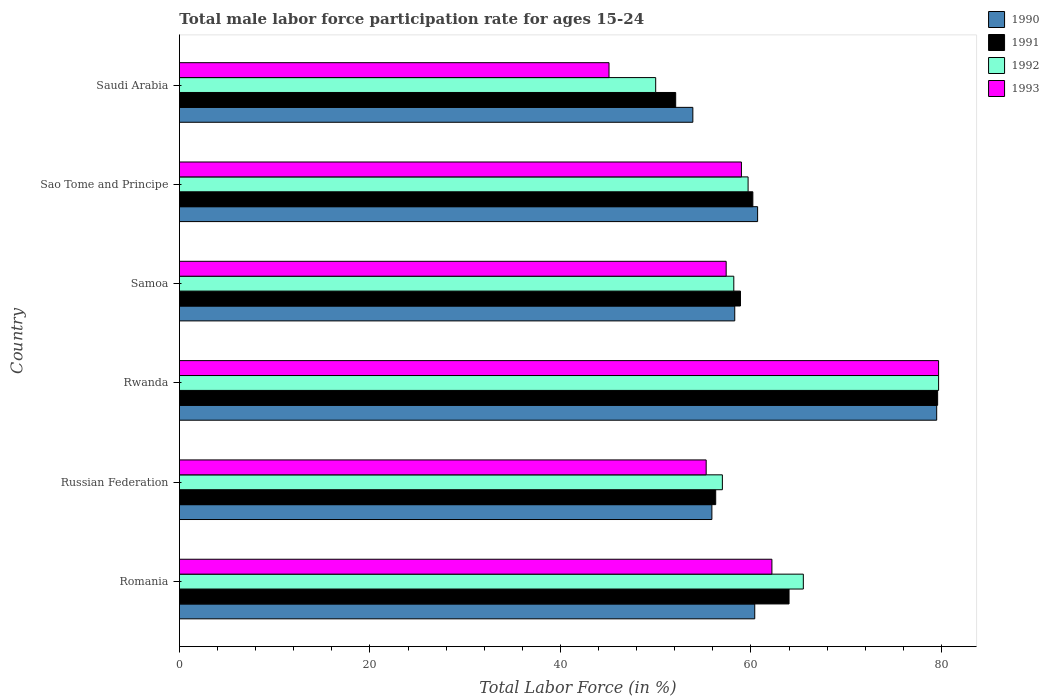Are the number of bars per tick equal to the number of legend labels?
Your answer should be compact. Yes. How many bars are there on the 2nd tick from the top?
Your answer should be very brief. 4. What is the label of the 3rd group of bars from the top?
Give a very brief answer. Samoa. In how many cases, is the number of bars for a given country not equal to the number of legend labels?
Provide a short and direct response. 0. Across all countries, what is the maximum male labor force participation rate in 1991?
Make the answer very short. 79.6. In which country was the male labor force participation rate in 1993 maximum?
Offer a terse response. Rwanda. In which country was the male labor force participation rate in 1993 minimum?
Your response must be concise. Saudi Arabia. What is the total male labor force participation rate in 1990 in the graph?
Ensure brevity in your answer.  368.7. What is the difference between the male labor force participation rate in 1993 in Samoa and that in Sao Tome and Principe?
Your answer should be compact. -1.6. What is the difference between the male labor force participation rate in 1991 in Romania and the male labor force participation rate in 1990 in Samoa?
Keep it short and to the point. 5.7. What is the average male labor force participation rate in 1991 per country?
Keep it short and to the point. 61.85. What is the difference between the male labor force participation rate in 1990 and male labor force participation rate in 1993 in Russian Federation?
Your answer should be compact. 0.6. In how many countries, is the male labor force participation rate in 1992 greater than 64 %?
Your answer should be compact. 2. What is the ratio of the male labor force participation rate in 1992 in Rwanda to that in Sao Tome and Principe?
Provide a short and direct response. 1.34. Is the difference between the male labor force participation rate in 1990 in Romania and Russian Federation greater than the difference between the male labor force participation rate in 1993 in Romania and Russian Federation?
Make the answer very short. No. What is the difference between the highest and the second highest male labor force participation rate in 1993?
Provide a succinct answer. 17.5. What is the difference between the highest and the lowest male labor force participation rate in 1993?
Ensure brevity in your answer.  34.6. In how many countries, is the male labor force participation rate in 1990 greater than the average male labor force participation rate in 1990 taken over all countries?
Provide a short and direct response. 1. What does the 4th bar from the top in Sao Tome and Principe represents?
Your answer should be very brief. 1990. What does the 1st bar from the bottom in Romania represents?
Offer a very short reply. 1990. Are the values on the major ticks of X-axis written in scientific E-notation?
Your response must be concise. No. Does the graph contain any zero values?
Offer a very short reply. No. Where does the legend appear in the graph?
Provide a succinct answer. Top right. How are the legend labels stacked?
Offer a terse response. Vertical. What is the title of the graph?
Make the answer very short. Total male labor force participation rate for ages 15-24. What is the label or title of the X-axis?
Offer a very short reply. Total Labor Force (in %). What is the Total Labor Force (in %) in 1990 in Romania?
Offer a terse response. 60.4. What is the Total Labor Force (in %) in 1992 in Romania?
Give a very brief answer. 65.5. What is the Total Labor Force (in %) of 1993 in Romania?
Your answer should be compact. 62.2. What is the Total Labor Force (in %) in 1990 in Russian Federation?
Your answer should be very brief. 55.9. What is the Total Labor Force (in %) in 1991 in Russian Federation?
Your answer should be compact. 56.3. What is the Total Labor Force (in %) in 1992 in Russian Federation?
Offer a terse response. 57. What is the Total Labor Force (in %) in 1993 in Russian Federation?
Your answer should be very brief. 55.3. What is the Total Labor Force (in %) in 1990 in Rwanda?
Keep it short and to the point. 79.5. What is the Total Labor Force (in %) of 1991 in Rwanda?
Provide a succinct answer. 79.6. What is the Total Labor Force (in %) in 1992 in Rwanda?
Offer a terse response. 79.7. What is the Total Labor Force (in %) in 1993 in Rwanda?
Your answer should be compact. 79.7. What is the Total Labor Force (in %) of 1990 in Samoa?
Provide a succinct answer. 58.3. What is the Total Labor Force (in %) in 1991 in Samoa?
Your response must be concise. 58.9. What is the Total Labor Force (in %) of 1992 in Samoa?
Provide a short and direct response. 58.2. What is the Total Labor Force (in %) in 1993 in Samoa?
Offer a very short reply. 57.4. What is the Total Labor Force (in %) in 1990 in Sao Tome and Principe?
Provide a succinct answer. 60.7. What is the Total Labor Force (in %) of 1991 in Sao Tome and Principe?
Make the answer very short. 60.2. What is the Total Labor Force (in %) in 1992 in Sao Tome and Principe?
Your response must be concise. 59.7. What is the Total Labor Force (in %) in 1993 in Sao Tome and Principe?
Provide a succinct answer. 59. What is the Total Labor Force (in %) of 1990 in Saudi Arabia?
Your response must be concise. 53.9. What is the Total Labor Force (in %) of 1991 in Saudi Arabia?
Keep it short and to the point. 52.1. What is the Total Labor Force (in %) in 1992 in Saudi Arabia?
Offer a terse response. 50. What is the Total Labor Force (in %) in 1993 in Saudi Arabia?
Provide a short and direct response. 45.1. Across all countries, what is the maximum Total Labor Force (in %) of 1990?
Offer a terse response. 79.5. Across all countries, what is the maximum Total Labor Force (in %) in 1991?
Your answer should be very brief. 79.6. Across all countries, what is the maximum Total Labor Force (in %) of 1992?
Your answer should be very brief. 79.7. Across all countries, what is the maximum Total Labor Force (in %) of 1993?
Ensure brevity in your answer.  79.7. Across all countries, what is the minimum Total Labor Force (in %) of 1990?
Your answer should be compact. 53.9. Across all countries, what is the minimum Total Labor Force (in %) of 1991?
Give a very brief answer. 52.1. Across all countries, what is the minimum Total Labor Force (in %) in 1992?
Your answer should be very brief. 50. Across all countries, what is the minimum Total Labor Force (in %) of 1993?
Your answer should be compact. 45.1. What is the total Total Labor Force (in %) in 1990 in the graph?
Offer a very short reply. 368.7. What is the total Total Labor Force (in %) of 1991 in the graph?
Your response must be concise. 371.1. What is the total Total Labor Force (in %) of 1992 in the graph?
Offer a very short reply. 370.1. What is the total Total Labor Force (in %) of 1993 in the graph?
Offer a very short reply. 358.7. What is the difference between the Total Labor Force (in %) in 1991 in Romania and that in Russian Federation?
Ensure brevity in your answer.  7.7. What is the difference between the Total Labor Force (in %) in 1993 in Romania and that in Russian Federation?
Make the answer very short. 6.9. What is the difference between the Total Labor Force (in %) in 1990 in Romania and that in Rwanda?
Your answer should be very brief. -19.1. What is the difference between the Total Labor Force (in %) of 1991 in Romania and that in Rwanda?
Your response must be concise. -15.6. What is the difference between the Total Labor Force (in %) of 1992 in Romania and that in Rwanda?
Your answer should be compact. -14.2. What is the difference between the Total Labor Force (in %) in 1993 in Romania and that in Rwanda?
Offer a terse response. -17.5. What is the difference between the Total Labor Force (in %) in 1990 in Romania and that in Samoa?
Your response must be concise. 2.1. What is the difference between the Total Labor Force (in %) in 1992 in Romania and that in Samoa?
Keep it short and to the point. 7.3. What is the difference between the Total Labor Force (in %) in 1990 in Romania and that in Sao Tome and Principe?
Provide a succinct answer. -0.3. What is the difference between the Total Labor Force (in %) in 1991 in Romania and that in Sao Tome and Principe?
Your answer should be very brief. 3.8. What is the difference between the Total Labor Force (in %) of 1992 in Romania and that in Sao Tome and Principe?
Ensure brevity in your answer.  5.8. What is the difference between the Total Labor Force (in %) in 1990 in Romania and that in Saudi Arabia?
Ensure brevity in your answer.  6.5. What is the difference between the Total Labor Force (in %) in 1992 in Romania and that in Saudi Arabia?
Your answer should be compact. 15.5. What is the difference between the Total Labor Force (in %) of 1990 in Russian Federation and that in Rwanda?
Make the answer very short. -23.6. What is the difference between the Total Labor Force (in %) in 1991 in Russian Federation and that in Rwanda?
Your answer should be very brief. -23.3. What is the difference between the Total Labor Force (in %) in 1992 in Russian Federation and that in Rwanda?
Offer a very short reply. -22.7. What is the difference between the Total Labor Force (in %) in 1993 in Russian Federation and that in Rwanda?
Your answer should be very brief. -24.4. What is the difference between the Total Labor Force (in %) in 1990 in Russian Federation and that in Samoa?
Give a very brief answer. -2.4. What is the difference between the Total Labor Force (in %) in 1991 in Russian Federation and that in Samoa?
Your answer should be compact. -2.6. What is the difference between the Total Labor Force (in %) in 1992 in Russian Federation and that in Sao Tome and Principe?
Your response must be concise. -2.7. What is the difference between the Total Labor Force (in %) of 1993 in Russian Federation and that in Sao Tome and Principe?
Provide a succinct answer. -3.7. What is the difference between the Total Labor Force (in %) in 1992 in Russian Federation and that in Saudi Arabia?
Your answer should be very brief. 7. What is the difference between the Total Labor Force (in %) in 1990 in Rwanda and that in Samoa?
Offer a very short reply. 21.2. What is the difference between the Total Labor Force (in %) of 1991 in Rwanda and that in Samoa?
Keep it short and to the point. 20.7. What is the difference between the Total Labor Force (in %) of 1992 in Rwanda and that in Samoa?
Provide a short and direct response. 21.5. What is the difference between the Total Labor Force (in %) of 1993 in Rwanda and that in Samoa?
Provide a short and direct response. 22.3. What is the difference between the Total Labor Force (in %) in 1991 in Rwanda and that in Sao Tome and Principe?
Offer a very short reply. 19.4. What is the difference between the Total Labor Force (in %) of 1992 in Rwanda and that in Sao Tome and Principe?
Offer a very short reply. 20. What is the difference between the Total Labor Force (in %) of 1993 in Rwanda and that in Sao Tome and Principe?
Your answer should be very brief. 20.7. What is the difference between the Total Labor Force (in %) of 1990 in Rwanda and that in Saudi Arabia?
Ensure brevity in your answer.  25.6. What is the difference between the Total Labor Force (in %) in 1991 in Rwanda and that in Saudi Arabia?
Offer a terse response. 27.5. What is the difference between the Total Labor Force (in %) in 1992 in Rwanda and that in Saudi Arabia?
Provide a short and direct response. 29.7. What is the difference between the Total Labor Force (in %) in 1993 in Rwanda and that in Saudi Arabia?
Your response must be concise. 34.6. What is the difference between the Total Labor Force (in %) of 1991 in Samoa and that in Sao Tome and Principe?
Offer a terse response. -1.3. What is the difference between the Total Labor Force (in %) in 1992 in Samoa and that in Sao Tome and Principe?
Keep it short and to the point. -1.5. What is the difference between the Total Labor Force (in %) of 1990 in Samoa and that in Saudi Arabia?
Make the answer very short. 4.4. What is the difference between the Total Labor Force (in %) of 1991 in Samoa and that in Saudi Arabia?
Give a very brief answer. 6.8. What is the difference between the Total Labor Force (in %) of 1992 in Samoa and that in Saudi Arabia?
Provide a short and direct response. 8.2. What is the difference between the Total Labor Force (in %) in 1993 in Samoa and that in Saudi Arabia?
Offer a terse response. 12.3. What is the difference between the Total Labor Force (in %) of 1990 in Sao Tome and Principe and that in Saudi Arabia?
Your answer should be very brief. 6.8. What is the difference between the Total Labor Force (in %) in 1991 in Sao Tome and Principe and that in Saudi Arabia?
Keep it short and to the point. 8.1. What is the difference between the Total Labor Force (in %) in 1992 in Sao Tome and Principe and that in Saudi Arabia?
Give a very brief answer. 9.7. What is the difference between the Total Labor Force (in %) in 1993 in Sao Tome and Principe and that in Saudi Arabia?
Your answer should be very brief. 13.9. What is the difference between the Total Labor Force (in %) in 1991 in Romania and the Total Labor Force (in %) in 1993 in Russian Federation?
Ensure brevity in your answer.  8.7. What is the difference between the Total Labor Force (in %) of 1990 in Romania and the Total Labor Force (in %) of 1991 in Rwanda?
Keep it short and to the point. -19.2. What is the difference between the Total Labor Force (in %) of 1990 in Romania and the Total Labor Force (in %) of 1992 in Rwanda?
Your response must be concise. -19.3. What is the difference between the Total Labor Force (in %) of 1990 in Romania and the Total Labor Force (in %) of 1993 in Rwanda?
Your response must be concise. -19.3. What is the difference between the Total Labor Force (in %) in 1991 in Romania and the Total Labor Force (in %) in 1992 in Rwanda?
Your answer should be compact. -15.7. What is the difference between the Total Labor Force (in %) of 1991 in Romania and the Total Labor Force (in %) of 1993 in Rwanda?
Provide a succinct answer. -15.7. What is the difference between the Total Labor Force (in %) of 1992 in Romania and the Total Labor Force (in %) of 1993 in Rwanda?
Give a very brief answer. -14.2. What is the difference between the Total Labor Force (in %) of 1990 in Romania and the Total Labor Force (in %) of 1993 in Samoa?
Provide a short and direct response. 3. What is the difference between the Total Labor Force (in %) of 1991 in Romania and the Total Labor Force (in %) of 1992 in Samoa?
Keep it short and to the point. 5.8. What is the difference between the Total Labor Force (in %) in 1991 in Romania and the Total Labor Force (in %) in 1993 in Samoa?
Make the answer very short. 6.6. What is the difference between the Total Labor Force (in %) in 1990 in Romania and the Total Labor Force (in %) in 1991 in Sao Tome and Principe?
Make the answer very short. 0.2. What is the difference between the Total Labor Force (in %) of 1990 in Romania and the Total Labor Force (in %) of 1992 in Sao Tome and Principe?
Offer a very short reply. 0.7. What is the difference between the Total Labor Force (in %) in 1990 in Romania and the Total Labor Force (in %) in 1993 in Sao Tome and Principe?
Keep it short and to the point. 1.4. What is the difference between the Total Labor Force (in %) in 1992 in Romania and the Total Labor Force (in %) in 1993 in Sao Tome and Principe?
Provide a succinct answer. 6.5. What is the difference between the Total Labor Force (in %) of 1990 in Romania and the Total Labor Force (in %) of 1992 in Saudi Arabia?
Keep it short and to the point. 10.4. What is the difference between the Total Labor Force (in %) in 1991 in Romania and the Total Labor Force (in %) in 1993 in Saudi Arabia?
Make the answer very short. 18.9. What is the difference between the Total Labor Force (in %) in 1992 in Romania and the Total Labor Force (in %) in 1993 in Saudi Arabia?
Provide a short and direct response. 20.4. What is the difference between the Total Labor Force (in %) of 1990 in Russian Federation and the Total Labor Force (in %) of 1991 in Rwanda?
Provide a succinct answer. -23.7. What is the difference between the Total Labor Force (in %) in 1990 in Russian Federation and the Total Labor Force (in %) in 1992 in Rwanda?
Provide a succinct answer. -23.8. What is the difference between the Total Labor Force (in %) of 1990 in Russian Federation and the Total Labor Force (in %) of 1993 in Rwanda?
Your response must be concise. -23.8. What is the difference between the Total Labor Force (in %) in 1991 in Russian Federation and the Total Labor Force (in %) in 1992 in Rwanda?
Make the answer very short. -23.4. What is the difference between the Total Labor Force (in %) of 1991 in Russian Federation and the Total Labor Force (in %) of 1993 in Rwanda?
Your response must be concise. -23.4. What is the difference between the Total Labor Force (in %) in 1992 in Russian Federation and the Total Labor Force (in %) in 1993 in Rwanda?
Ensure brevity in your answer.  -22.7. What is the difference between the Total Labor Force (in %) of 1990 in Russian Federation and the Total Labor Force (in %) of 1992 in Samoa?
Offer a very short reply. -2.3. What is the difference between the Total Labor Force (in %) of 1991 in Russian Federation and the Total Labor Force (in %) of 1993 in Samoa?
Your answer should be very brief. -1.1. What is the difference between the Total Labor Force (in %) in 1990 in Russian Federation and the Total Labor Force (in %) in 1991 in Sao Tome and Principe?
Offer a very short reply. -4.3. What is the difference between the Total Labor Force (in %) in 1992 in Russian Federation and the Total Labor Force (in %) in 1993 in Sao Tome and Principe?
Your response must be concise. -2. What is the difference between the Total Labor Force (in %) of 1990 in Russian Federation and the Total Labor Force (in %) of 1992 in Saudi Arabia?
Your response must be concise. 5.9. What is the difference between the Total Labor Force (in %) in 1990 in Russian Federation and the Total Labor Force (in %) in 1993 in Saudi Arabia?
Provide a succinct answer. 10.8. What is the difference between the Total Labor Force (in %) of 1991 in Russian Federation and the Total Labor Force (in %) of 1993 in Saudi Arabia?
Ensure brevity in your answer.  11.2. What is the difference between the Total Labor Force (in %) in 1992 in Russian Federation and the Total Labor Force (in %) in 1993 in Saudi Arabia?
Keep it short and to the point. 11.9. What is the difference between the Total Labor Force (in %) of 1990 in Rwanda and the Total Labor Force (in %) of 1991 in Samoa?
Offer a very short reply. 20.6. What is the difference between the Total Labor Force (in %) of 1990 in Rwanda and the Total Labor Force (in %) of 1992 in Samoa?
Give a very brief answer. 21.3. What is the difference between the Total Labor Force (in %) in 1990 in Rwanda and the Total Labor Force (in %) in 1993 in Samoa?
Your answer should be very brief. 22.1. What is the difference between the Total Labor Force (in %) in 1991 in Rwanda and the Total Labor Force (in %) in 1992 in Samoa?
Give a very brief answer. 21.4. What is the difference between the Total Labor Force (in %) in 1991 in Rwanda and the Total Labor Force (in %) in 1993 in Samoa?
Your response must be concise. 22.2. What is the difference between the Total Labor Force (in %) of 1992 in Rwanda and the Total Labor Force (in %) of 1993 in Samoa?
Provide a short and direct response. 22.3. What is the difference between the Total Labor Force (in %) in 1990 in Rwanda and the Total Labor Force (in %) in 1991 in Sao Tome and Principe?
Provide a succinct answer. 19.3. What is the difference between the Total Labor Force (in %) of 1990 in Rwanda and the Total Labor Force (in %) of 1992 in Sao Tome and Principe?
Provide a short and direct response. 19.8. What is the difference between the Total Labor Force (in %) of 1991 in Rwanda and the Total Labor Force (in %) of 1992 in Sao Tome and Principe?
Provide a short and direct response. 19.9. What is the difference between the Total Labor Force (in %) of 1991 in Rwanda and the Total Labor Force (in %) of 1993 in Sao Tome and Principe?
Your response must be concise. 20.6. What is the difference between the Total Labor Force (in %) in 1992 in Rwanda and the Total Labor Force (in %) in 1993 in Sao Tome and Principe?
Offer a terse response. 20.7. What is the difference between the Total Labor Force (in %) in 1990 in Rwanda and the Total Labor Force (in %) in 1991 in Saudi Arabia?
Keep it short and to the point. 27.4. What is the difference between the Total Labor Force (in %) in 1990 in Rwanda and the Total Labor Force (in %) in 1992 in Saudi Arabia?
Your answer should be compact. 29.5. What is the difference between the Total Labor Force (in %) of 1990 in Rwanda and the Total Labor Force (in %) of 1993 in Saudi Arabia?
Keep it short and to the point. 34.4. What is the difference between the Total Labor Force (in %) of 1991 in Rwanda and the Total Labor Force (in %) of 1992 in Saudi Arabia?
Your answer should be very brief. 29.6. What is the difference between the Total Labor Force (in %) in 1991 in Rwanda and the Total Labor Force (in %) in 1993 in Saudi Arabia?
Keep it short and to the point. 34.5. What is the difference between the Total Labor Force (in %) of 1992 in Rwanda and the Total Labor Force (in %) of 1993 in Saudi Arabia?
Provide a short and direct response. 34.6. What is the difference between the Total Labor Force (in %) of 1990 in Samoa and the Total Labor Force (in %) of 1991 in Sao Tome and Principe?
Make the answer very short. -1.9. What is the difference between the Total Labor Force (in %) in 1990 in Samoa and the Total Labor Force (in %) in 1992 in Sao Tome and Principe?
Make the answer very short. -1.4. What is the difference between the Total Labor Force (in %) of 1990 in Samoa and the Total Labor Force (in %) of 1993 in Sao Tome and Principe?
Ensure brevity in your answer.  -0.7. What is the difference between the Total Labor Force (in %) of 1991 in Samoa and the Total Labor Force (in %) of 1992 in Sao Tome and Principe?
Keep it short and to the point. -0.8. What is the difference between the Total Labor Force (in %) of 1992 in Samoa and the Total Labor Force (in %) of 1993 in Sao Tome and Principe?
Offer a terse response. -0.8. What is the difference between the Total Labor Force (in %) of 1990 in Samoa and the Total Labor Force (in %) of 1991 in Saudi Arabia?
Your answer should be very brief. 6.2. What is the difference between the Total Labor Force (in %) in 1990 in Samoa and the Total Labor Force (in %) in 1992 in Saudi Arabia?
Provide a succinct answer. 8.3. What is the difference between the Total Labor Force (in %) of 1991 in Samoa and the Total Labor Force (in %) of 1993 in Saudi Arabia?
Your response must be concise. 13.8. What is the difference between the Total Labor Force (in %) in 1990 in Sao Tome and Principe and the Total Labor Force (in %) in 1992 in Saudi Arabia?
Give a very brief answer. 10.7. What is the difference between the Total Labor Force (in %) in 1991 in Sao Tome and Principe and the Total Labor Force (in %) in 1992 in Saudi Arabia?
Your answer should be very brief. 10.2. What is the difference between the Total Labor Force (in %) in 1991 in Sao Tome and Principe and the Total Labor Force (in %) in 1993 in Saudi Arabia?
Provide a succinct answer. 15.1. What is the difference between the Total Labor Force (in %) of 1992 in Sao Tome and Principe and the Total Labor Force (in %) of 1993 in Saudi Arabia?
Your response must be concise. 14.6. What is the average Total Labor Force (in %) in 1990 per country?
Your answer should be very brief. 61.45. What is the average Total Labor Force (in %) in 1991 per country?
Give a very brief answer. 61.85. What is the average Total Labor Force (in %) in 1992 per country?
Provide a succinct answer. 61.68. What is the average Total Labor Force (in %) in 1993 per country?
Keep it short and to the point. 59.78. What is the difference between the Total Labor Force (in %) of 1990 and Total Labor Force (in %) of 1991 in Romania?
Provide a short and direct response. -3.6. What is the difference between the Total Labor Force (in %) of 1991 and Total Labor Force (in %) of 1993 in Russian Federation?
Provide a short and direct response. 1. What is the difference between the Total Labor Force (in %) in 1992 and Total Labor Force (in %) in 1993 in Russian Federation?
Make the answer very short. 1.7. What is the difference between the Total Labor Force (in %) of 1990 and Total Labor Force (in %) of 1991 in Rwanda?
Your response must be concise. -0.1. What is the difference between the Total Labor Force (in %) in 1990 and Total Labor Force (in %) in 1992 in Rwanda?
Keep it short and to the point. -0.2. What is the difference between the Total Labor Force (in %) of 1991 and Total Labor Force (in %) of 1992 in Rwanda?
Your answer should be very brief. -0.1. What is the difference between the Total Labor Force (in %) of 1991 and Total Labor Force (in %) of 1993 in Rwanda?
Give a very brief answer. -0.1. What is the difference between the Total Labor Force (in %) of 1990 and Total Labor Force (in %) of 1991 in Samoa?
Your answer should be very brief. -0.6. What is the difference between the Total Labor Force (in %) in 1990 and Total Labor Force (in %) in 1992 in Samoa?
Offer a terse response. 0.1. What is the difference between the Total Labor Force (in %) of 1990 and Total Labor Force (in %) of 1993 in Samoa?
Ensure brevity in your answer.  0.9. What is the difference between the Total Labor Force (in %) of 1991 and Total Labor Force (in %) of 1992 in Samoa?
Ensure brevity in your answer.  0.7. What is the difference between the Total Labor Force (in %) in 1990 and Total Labor Force (in %) in 1991 in Sao Tome and Principe?
Make the answer very short. 0.5. What is the difference between the Total Labor Force (in %) of 1990 and Total Labor Force (in %) of 1992 in Sao Tome and Principe?
Your answer should be compact. 1. What is the difference between the Total Labor Force (in %) in 1990 and Total Labor Force (in %) in 1993 in Sao Tome and Principe?
Make the answer very short. 1.7. What is the difference between the Total Labor Force (in %) in 1991 and Total Labor Force (in %) in 1992 in Sao Tome and Principe?
Your answer should be very brief. 0.5. What is the difference between the Total Labor Force (in %) in 1991 and Total Labor Force (in %) in 1992 in Saudi Arabia?
Offer a very short reply. 2.1. What is the difference between the Total Labor Force (in %) in 1992 and Total Labor Force (in %) in 1993 in Saudi Arabia?
Keep it short and to the point. 4.9. What is the ratio of the Total Labor Force (in %) of 1990 in Romania to that in Russian Federation?
Provide a succinct answer. 1.08. What is the ratio of the Total Labor Force (in %) of 1991 in Romania to that in Russian Federation?
Provide a succinct answer. 1.14. What is the ratio of the Total Labor Force (in %) in 1992 in Romania to that in Russian Federation?
Provide a succinct answer. 1.15. What is the ratio of the Total Labor Force (in %) of 1993 in Romania to that in Russian Federation?
Your answer should be compact. 1.12. What is the ratio of the Total Labor Force (in %) in 1990 in Romania to that in Rwanda?
Offer a terse response. 0.76. What is the ratio of the Total Labor Force (in %) of 1991 in Romania to that in Rwanda?
Provide a short and direct response. 0.8. What is the ratio of the Total Labor Force (in %) of 1992 in Romania to that in Rwanda?
Your answer should be very brief. 0.82. What is the ratio of the Total Labor Force (in %) in 1993 in Romania to that in Rwanda?
Offer a terse response. 0.78. What is the ratio of the Total Labor Force (in %) of 1990 in Romania to that in Samoa?
Make the answer very short. 1.04. What is the ratio of the Total Labor Force (in %) in 1991 in Romania to that in Samoa?
Keep it short and to the point. 1.09. What is the ratio of the Total Labor Force (in %) in 1992 in Romania to that in Samoa?
Ensure brevity in your answer.  1.13. What is the ratio of the Total Labor Force (in %) in 1993 in Romania to that in Samoa?
Ensure brevity in your answer.  1.08. What is the ratio of the Total Labor Force (in %) of 1990 in Romania to that in Sao Tome and Principe?
Provide a succinct answer. 1. What is the ratio of the Total Labor Force (in %) of 1991 in Romania to that in Sao Tome and Principe?
Keep it short and to the point. 1.06. What is the ratio of the Total Labor Force (in %) in 1992 in Romania to that in Sao Tome and Principe?
Offer a very short reply. 1.1. What is the ratio of the Total Labor Force (in %) of 1993 in Romania to that in Sao Tome and Principe?
Make the answer very short. 1.05. What is the ratio of the Total Labor Force (in %) of 1990 in Romania to that in Saudi Arabia?
Offer a very short reply. 1.12. What is the ratio of the Total Labor Force (in %) in 1991 in Romania to that in Saudi Arabia?
Ensure brevity in your answer.  1.23. What is the ratio of the Total Labor Force (in %) in 1992 in Romania to that in Saudi Arabia?
Provide a succinct answer. 1.31. What is the ratio of the Total Labor Force (in %) in 1993 in Romania to that in Saudi Arabia?
Provide a short and direct response. 1.38. What is the ratio of the Total Labor Force (in %) of 1990 in Russian Federation to that in Rwanda?
Offer a terse response. 0.7. What is the ratio of the Total Labor Force (in %) of 1991 in Russian Federation to that in Rwanda?
Offer a very short reply. 0.71. What is the ratio of the Total Labor Force (in %) of 1992 in Russian Federation to that in Rwanda?
Give a very brief answer. 0.72. What is the ratio of the Total Labor Force (in %) in 1993 in Russian Federation to that in Rwanda?
Give a very brief answer. 0.69. What is the ratio of the Total Labor Force (in %) in 1990 in Russian Federation to that in Samoa?
Your response must be concise. 0.96. What is the ratio of the Total Labor Force (in %) of 1991 in Russian Federation to that in Samoa?
Provide a succinct answer. 0.96. What is the ratio of the Total Labor Force (in %) of 1992 in Russian Federation to that in Samoa?
Offer a very short reply. 0.98. What is the ratio of the Total Labor Force (in %) of 1993 in Russian Federation to that in Samoa?
Provide a succinct answer. 0.96. What is the ratio of the Total Labor Force (in %) of 1990 in Russian Federation to that in Sao Tome and Principe?
Keep it short and to the point. 0.92. What is the ratio of the Total Labor Force (in %) in 1991 in Russian Federation to that in Sao Tome and Principe?
Ensure brevity in your answer.  0.94. What is the ratio of the Total Labor Force (in %) in 1992 in Russian Federation to that in Sao Tome and Principe?
Give a very brief answer. 0.95. What is the ratio of the Total Labor Force (in %) of 1993 in Russian Federation to that in Sao Tome and Principe?
Your response must be concise. 0.94. What is the ratio of the Total Labor Force (in %) of 1990 in Russian Federation to that in Saudi Arabia?
Give a very brief answer. 1.04. What is the ratio of the Total Labor Force (in %) of 1991 in Russian Federation to that in Saudi Arabia?
Keep it short and to the point. 1.08. What is the ratio of the Total Labor Force (in %) in 1992 in Russian Federation to that in Saudi Arabia?
Offer a very short reply. 1.14. What is the ratio of the Total Labor Force (in %) of 1993 in Russian Federation to that in Saudi Arabia?
Your response must be concise. 1.23. What is the ratio of the Total Labor Force (in %) of 1990 in Rwanda to that in Samoa?
Offer a very short reply. 1.36. What is the ratio of the Total Labor Force (in %) of 1991 in Rwanda to that in Samoa?
Offer a terse response. 1.35. What is the ratio of the Total Labor Force (in %) in 1992 in Rwanda to that in Samoa?
Ensure brevity in your answer.  1.37. What is the ratio of the Total Labor Force (in %) of 1993 in Rwanda to that in Samoa?
Provide a succinct answer. 1.39. What is the ratio of the Total Labor Force (in %) in 1990 in Rwanda to that in Sao Tome and Principe?
Offer a terse response. 1.31. What is the ratio of the Total Labor Force (in %) of 1991 in Rwanda to that in Sao Tome and Principe?
Your response must be concise. 1.32. What is the ratio of the Total Labor Force (in %) of 1992 in Rwanda to that in Sao Tome and Principe?
Your answer should be very brief. 1.33. What is the ratio of the Total Labor Force (in %) of 1993 in Rwanda to that in Sao Tome and Principe?
Offer a terse response. 1.35. What is the ratio of the Total Labor Force (in %) in 1990 in Rwanda to that in Saudi Arabia?
Provide a succinct answer. 1.48. What is the ratio of the Total Labor Force (in %) of 1991 in Rwanda to that in Saudi Arabia?
Ensure brevity in your answer.  1.53. What is the ratio of the Total Labor Force (in %) of 1992 in Rwanda to that in Saudi Arabia?
Offer a very short reply. 1.59. What is the ratio of the Total Labor Force (in %) of 1993 in Rwanda to that in Saudi Arabia?
Offer a very short reply. 1.77. What is the ratio of the Total Labor Force (in %) of 1990 in Samoa to that in Sao Tome and Principe?
Offer a very short reply. 0.96. What is the ratio of the Total Labor Force (in %) in 1991 in Samoa to that in Sao Tome and Principe?
Your response must be concise. 0.98. What is the ratio of the Total Labor Force (in %) in 1992 in Samoa to that in Sao Tome and Principe?
Provide a short and direct response. 0.97. What is the ratio of the Total Labor Force (in %) of 1993 in Samoa to that in Sao Tome and Principe?
Your answer should be very brief. 0.97. What is the ratio of the Total Labor Force (in %) in 1990 in Samoa to that in Saudi Arabia?
Offer a terse response. 1.08. What is the ratio of the Total Labor Force (in %) in 1991 in Samoa to that in Saudi Arabia?
Ensure brevity in your answer.  1.13. What is the ratio of the Total Labor Force (in %) of 1992 in Samoa to that in Saudi Arabia?
Your answer should be very brief. 1.16. What is the ratio of the Total Labor Force (in %) of 1993 in Samoa to that in Saudi Arabia?
Provide a succinct answer. 1.27. What is the ratio of the Total Labor Force (in %) in 1990 in Sao Tome and Principe to that in Saudi Arabia?
Offer a terse response. 1.13. What is the ratio of the Total Labor Force (in %) in 1991 in Sao Tome and Principe to that in Saudi Arabia?
Your response must be concise. 1.16. What is the ratio of the Total Labor Force (in %) of 1992 in Sao Tome and Principe to that in Saudi Arabia?
Your answer should be compact. 1.19. What is the ratio of the Total Labor Force (in %) in 1993 in Sao Tome and Principe to that in Saudi Arabia?
Keep it short and to the point. 1.31. What is the difference between the highest and the second highest Total Labor Force (in %) of 1990?
Ensure brevity in your answer.  18.8. What is the difference between the highest and the second highest Total Labor Force (in %) of 1992?
Make the answer very short. 14.2. What is the difference between the highest and the second highest Total Labor Force (in %) of 1993?
Your answer should be compact. 17.5. What is the difference between the highest and the lowest Total Labor Force (in %) in 1990?
Offer a terse response. 25.6. What is the difference between the highest and the lowest Total Labor Force (in %) of 1992?
Offer a very short reply. 29.7. What is the difference between the highest and the lowest Total Labor Force (in %) in 1993?
Your answer should be very brief. 34.6. 